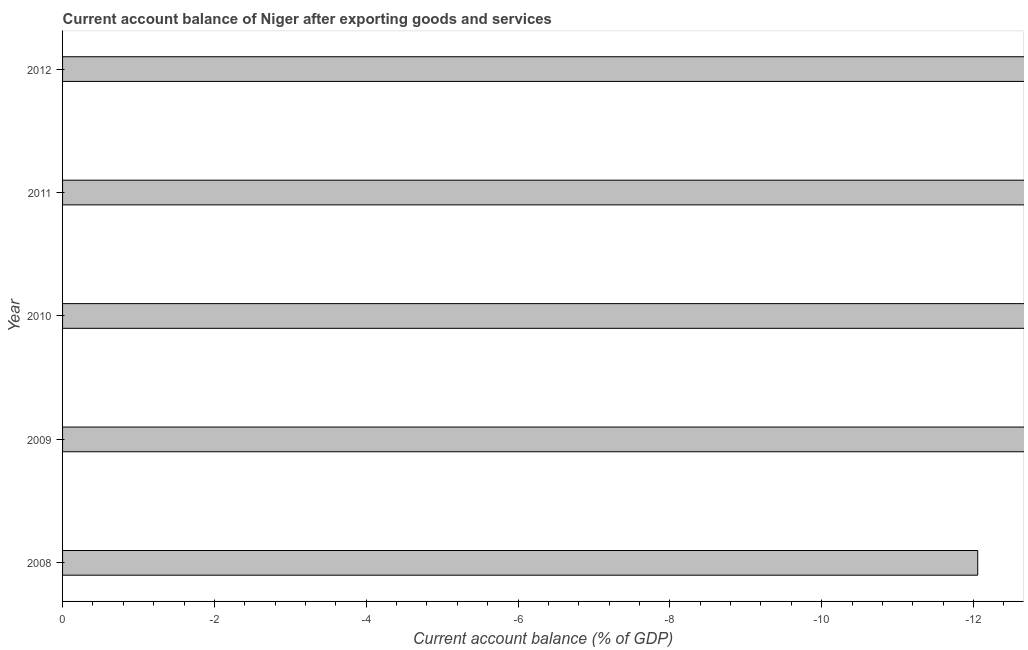Does the graph contain any zero values?
Your answer should be compact. Yes. Does the graph contain grids?
Your response must be concise. No. What is the title of the graph?
Ensure brevity in your answer.  Current account balance of Niger after exporting goods and services. What is the label or title of the X-axis?
Your answer should be compact. Current account balance (% of GDP). What is the sum of the current account balance?
Provide a succinct answer. 0. What is the average current account balance per year?
Keep it short and to the point. 0. What is the median current account balance?
Your response must be concise. 0. In how many years, is the current account balance greater than -10.8 %?
Provide a succinct answer. 0. How many years are there in the graph?
Keep it short and to the point. 5. What is the difference between two consecutive major ticks on the X-axis?
Keep it short and to the point. 2. Are the values on the major ticks of X-axis written in scientific E-notation?
Make the answer very short. No. What is the Current account balance (% of GDP) of 2008?
Ensure brevity in your answer.  0. What is the Current account balance (% of GDP) in 2009?
Ensure brevity in your answer.  0. What is the Current account balance (% of GDP) in 2011?
Your response must be concise. 0. 